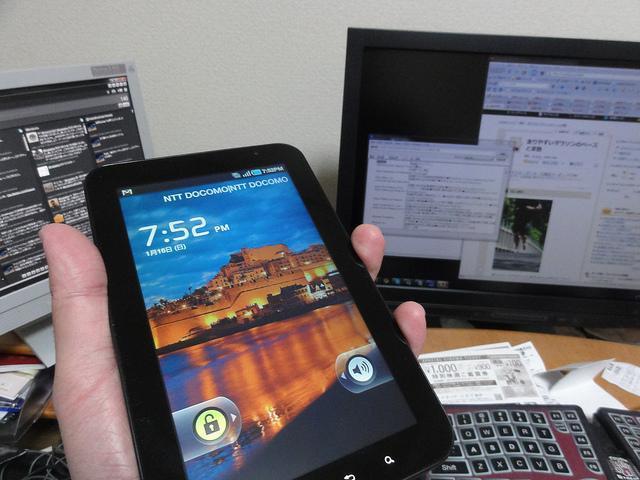How many tvs are visible?
Give a very brief answer. 2. How many hands does the clock have?
Give a very brief answer. 0. 